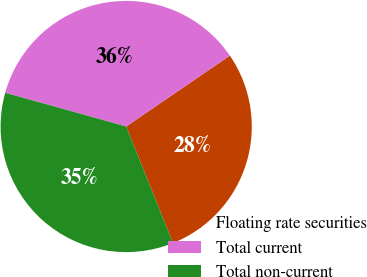<chart> <loc_0><loc_0><loc_500><loc_500><pie_chart><fcel>Floating rate securities<fcel>Total current<fcel>Total non-current<nl><fcel>28.47%<fcel>36.13%<fcel>35.4%<nl></chart> 